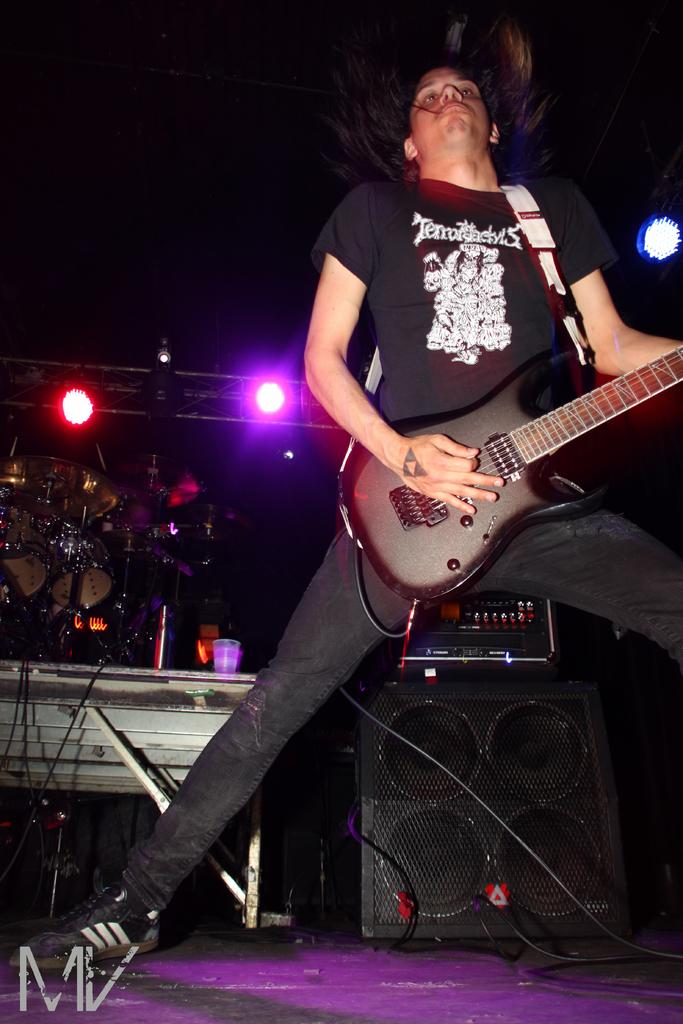What is the person in the image doing? The person is standing in the image and holding a guitar. What is the person standing on? The person is standing on the floor. What can be seen in the background of the image? There are lights visible in the background. How many chickens are visible in the image? There are no chickens present in the image. Are the person's sisters also visible in the image? The provided facts do not mention any sisters, so we cannot determine if they are visible in the image. 